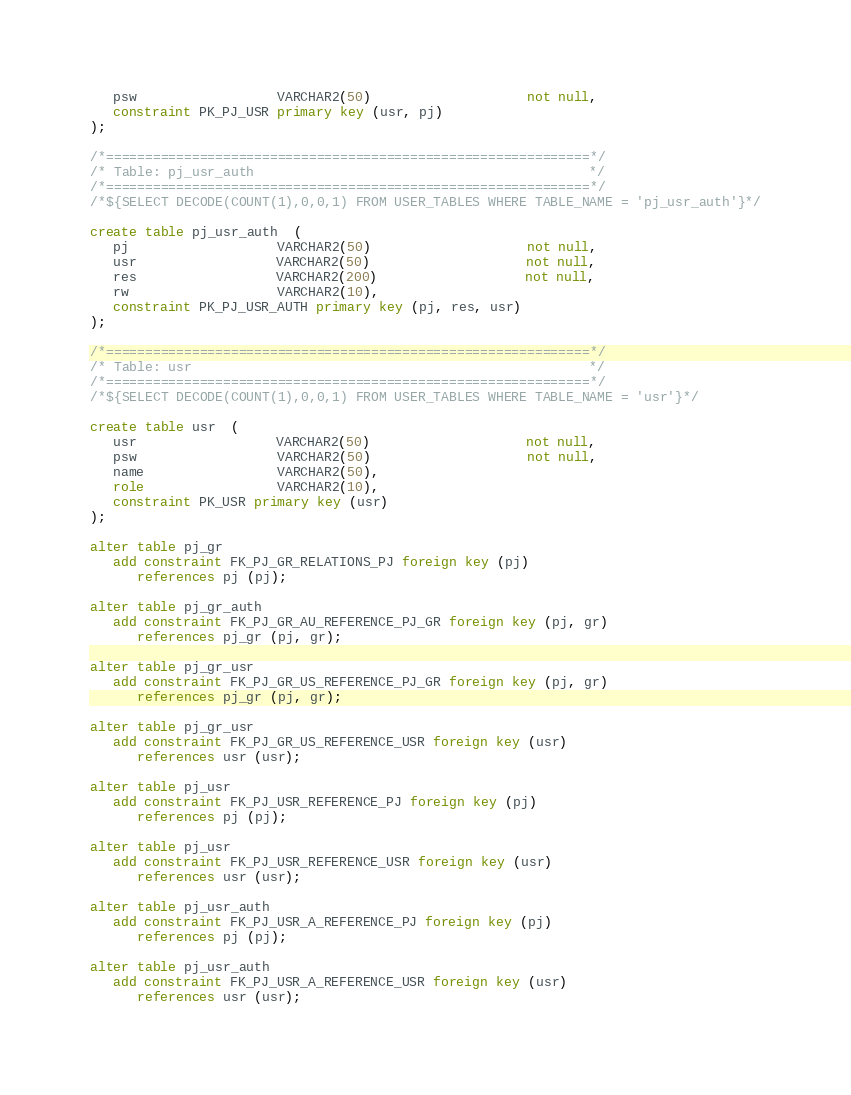<code> <loc_0><loc_0><loc_500><loc_500><_SQL_>   psw                  VARCHAR2(50)                    not null,
   constraint PK_PJ_USR primary key (usr, pj)
);

/*==============================================================*/
/* Table: pj_usr_auth                                           */
/*==============================================================*/
/*${SELECT DECODE(COUNT(1),0,0,1) FROM USER_TABLES WHERE TABLE_NAME = 'pj_usr_auth'}*/

create table pj_usr_auth  (
   pj                   VARCHAR2(50)                    not null,
   usr                  VARCHAR2(50)                    not null,
   res                  VARCHAR2(200)                   not null,
   rw                   VARCHAR2(10),
   constraint PK_PJ_USR_AUTH primary key (pj, res, usr)
);

/*==============================================================*/
/* Table: usr                                                   */
/*==============================================================*/
/*${SELECT DECODE(COUNT(1),0,0,1) FROM USER_TABLES WHERE TABLE_NAME = 'usr'}*/

create table usr  (
   usr                  VARCHAR2(50)                    not null,
   psw                  VARCHAR2(50)                    not null,
   name                 VARCHAR2(50),
   role                 VARCHAR2(10),
   constraint PK_USR primary key (usr)
);

alter table pj_gr
   add constraint FK_PJ_GR_RELATIONS_PJ foreign key (pj)
      references pj (pj);

alter table pj_gr_auth
   add constraint FK_PJ_GR_AU_REFERENCE_PJ_GR foreign key (pj, gr)
      references pj_gr (pj, gr);

alter table pj_gr_usr
   add constraint FK_PJ_GR_US_REFERENCE_PJ_GR foreign key (pj, gr)
      references pj_gr (pj, gr);

alter table pj_gr_usr
   add constraint FK_PJ_GR_US_REFERENCE_USR foreign key (usr)
      references usr (usr);

alter table pj_usr
   add constraint FK_PJ_USR_REFERENCE_PJ foreign key (pj)
      references pj (pj);

alter table pj_usr
   add constraint FK_PJ_USR_REFERENCE_USR foreign key (usr)
      references usr (usr);

alter table pj_usr_auth
   add constraint FK_PJ_USR_A_REFERENCE_PJ foreign key (pj)
      references pj (pj);

alter table pj_usr_auth
   add constraint FK_PJ_USR_A_REFERENCE_USR foreign key (usr)
      references usr (usr);

</code> 